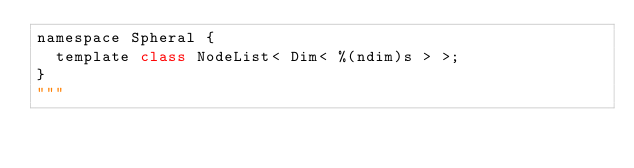Convert code to text. <code><loc_0><loc_0><loc_500><loc_500><_Python_>namespace Spheral {
  template class NodeList< Dim< %(ndim)s > >;
}
"""
</code> 